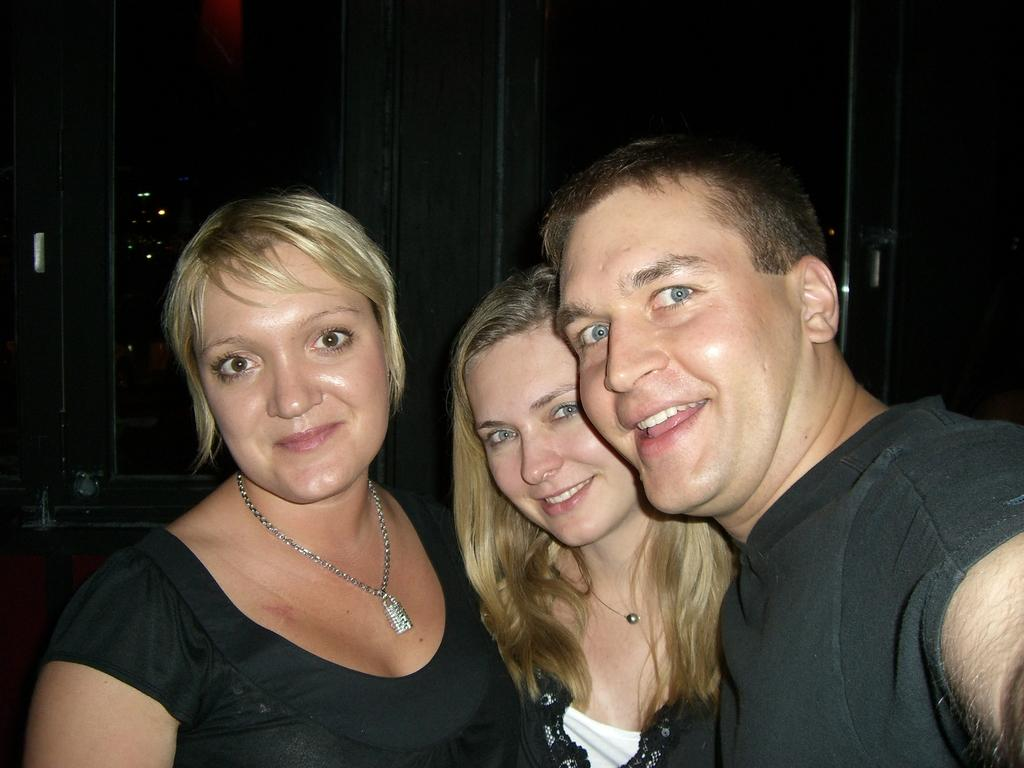How many people are in the image? There are three people in the image. What are the people doing in the image? The people are standing and smiling. What can be seen in the background of the image? There is a wall in the background of the image. What type of trousers is the front wearing in the image? There is no reference to a front or trousers in the image, as it features three people standing and smiling. 